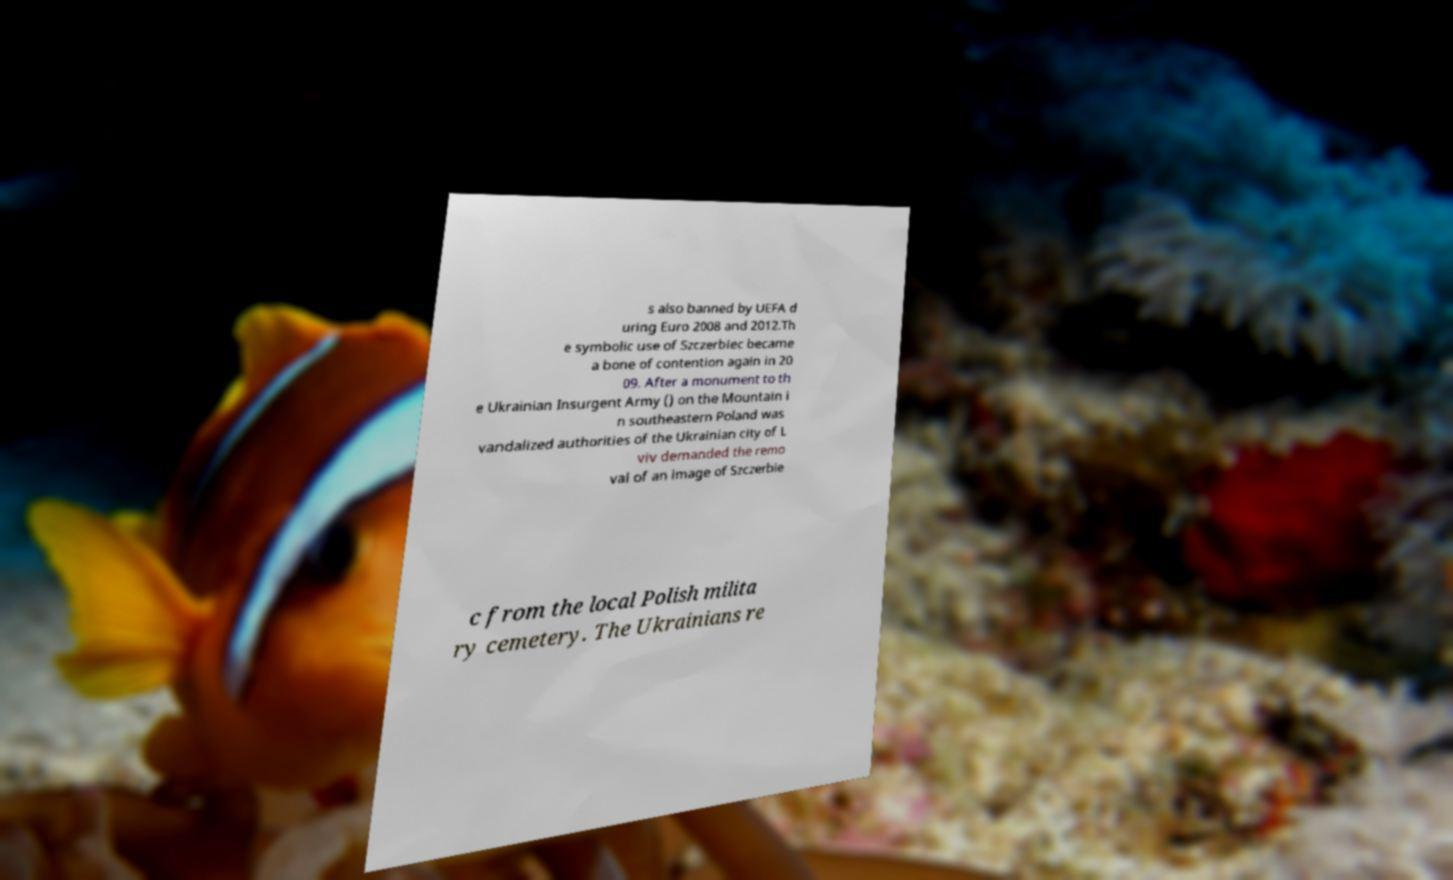Please identify and transcribe the text found in this image. s also banned by UEFA d uring Euro 2008 and 2012.Th e symbolic use of Szczerbiec became a bone of contention again in 20 09. After a monument to th e Ukrainian Insurgent Army () on the Mountain i n southeastern Poland was vandalized authorities of the Ukrainian city of L viv demanded the remo val of an image of Szczerbie c from the local Polish milita ry cemetery. The Ukrainians re 